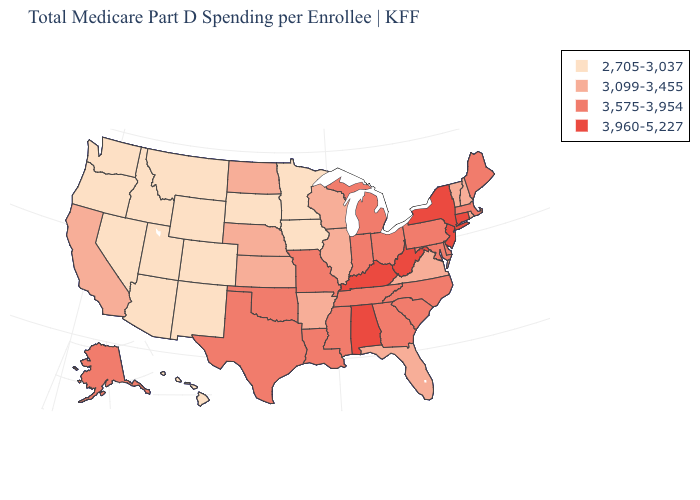What is the lowest value in states that border California?
Concise answer only. 2,705-3,037. What is the value of Montana?
Answer briefly. 2,705-3,037. What is the value of Tennessee?
Short answer required. 3,575-3,954. What is the value of Alabama?
Answer briefly. 3,960-5,227. Name the states that have a value in the range 3,575-3,954?
Be succinct. Alaska, Delaware, Georgia, Indiana, Louisiana, Maine, Maryland, Massachusetts, Michigan, Mississippi, Missouri, North Carolina, Ohio, Oklahoma, Pennsylvania, South Carolina, Tennessee, Texas. Does North Carolina have the lowest value in the USA?
Give a very brief answer. No. Does Florida have the same value as Vermont?
Quick response, please. Yes. What is the value of Ohio?
Answer briefly. 3,575-3,954. Name the states that have a value in the range 3,575-3,954?
Answer briefly. Alaska, Delaware, Georgia, Indiana, Louisiana, Maine, Maryland, Massachusetts, Michigan, Mississippi, Missouri, North Carolina, Ohio, Oklahoma, Pennsylvania, South Carolina, Tennessee, Texas. What is the value of Oklahoma?
Short answer required. 3,575-3,954. How many symbols are there in the legend?
Concise answer only. 4. Which states have the lowest value in the MidWest?
Concise answer only. Iowa, Minnesota, South Dakota. Name the states that have a value in the range 3,575-3,954?
Keep it brief. Alaska, Delaware, Georgia, Indiana, Louisiana, Maine, Maryland, Massachusetts, Michigan, Mississippi, Missouri, North Carolina, Ohio, Oklahoma, Pennsylvania, South Carolina, Tennessee, Texas. Does Kentucky have a lower value than Maryland?
Answer briefly. No. Name the states that have a value in the range 3,099-3,455?
Answer briefly. Arkansas, California, Florida, Illinois, Kansas, Nebraska, New Hampshire, North Dakota, Rhode Island, Vermont, Virginia, Wisconsin. 